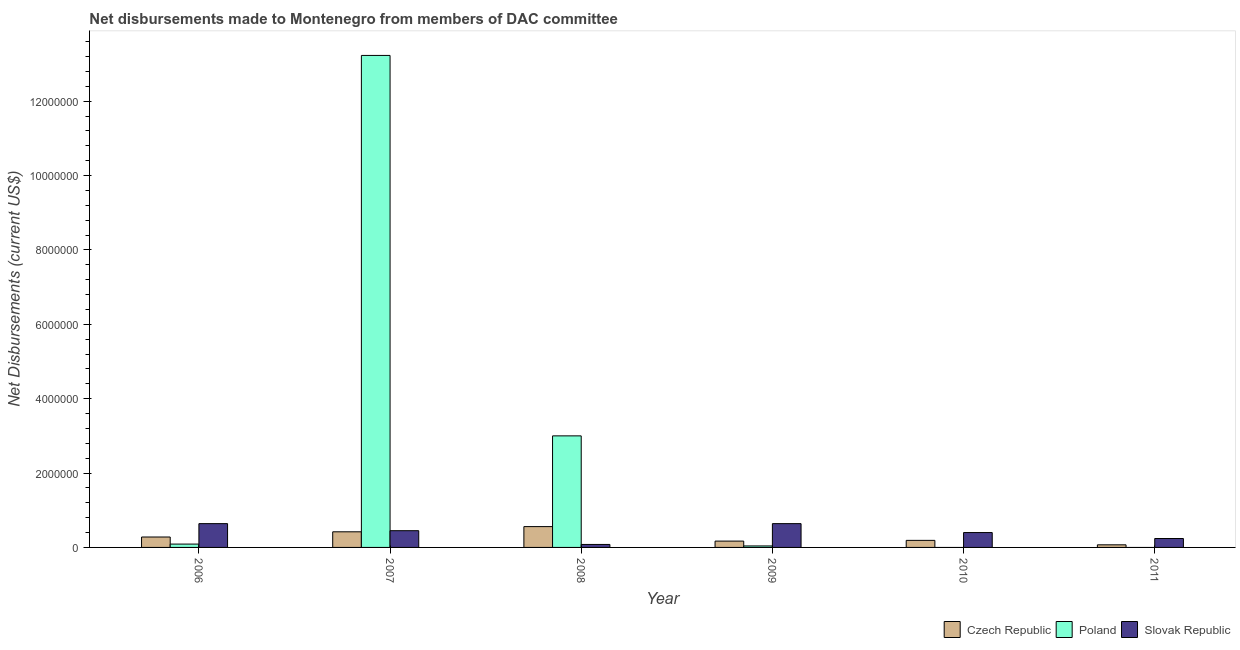How many different coloured bars are there?
Your answer should be compact. 3. How many bars are there on the 4th tick from the right?
Give a very brief answer. 3. In how many cases, is the number of bars for a given year not equal to the number of legend labels?
Ensure brevity in your answer.  2. What is the net disbursements made by czech republic in 2007?
Your answer should be very brief. 4.20e+05. Across all years, what is the maximum net disbursements made by slovak republic?
Provide a short and direct response. 6.40e+05. Across all years, what is the minimum net disbursements made by slovak republic?
Keep it short and to the point. 8.00e+04. In which year was the net disbursements made by slovak republic maximum?
Your answer should be compact. 2006. What is the total net disbursements made by czech republic in the graph?
Your response must be concise. 1.69e+06. What is the difference between the net disbursements made by czech republic in 2010 and that in 2011?
Your answer should be very brief. 1.20e+05. What is the difference between the net disbursements made by slovak republic in 2010 and the net disbursements made by poland in 2009?
Your answer should be very brief. -2.40e+05. What is the average net disbursements made by slovak republic per year?
Ensure brevity in your answer.  4.08e+05. In how many years, is the net disbursements made by slovak republic greater than 8800000 US$?
Give a very brief answer. 0. What is the ratio of the net disbursements made by czech republic in 2006 to that in 2008?
Give a very brief answer. 0.5. What is the difference between the highest and the second highest net disbursements made by poland?
Offer a very short reply. 1.02e+07. What is the difference between the highest and the lowest net disbursements made by poland?
Your answer should be very brief. 1.32e+07. In how many years, is the net disbursements made by slovak republic greater than the average net disbursements made by slovak republic taken over all years?
Provide a short and direct response. 3. Is the sum of the net disbursements made by slovak republic in 2007 and 2009 greater than the maximum net disbursements made by czech republic across all years?
Offer a terse response. Yes. Does the graph contain any zero values?
Provide a short and direct response. Yes. How are the legend labels stacked?
Provide a succinct answer. Horizontal. What is the title of the graph?
Keep it short and to the point. Net disbursements made to Montenegro from members of DAC committee. What is the label or title of the X-axis?
Provide a short and direct response. Year. What is the label or title of the Y-axis?
Give a very brief answer. Net Disbursements (current US$). What is the Net Disbursements (current US$) in Slovak Republic in 2006?
Keep it short and to the point. 6.40e+05. What is the Net Disbursements (current US$) of Poland in 2007?
Provide a succinct answer. 1.32e+07. What is the Net Disbursements (current US$) in Czech Republic in 2008?
Your answer should be very brief. 5.60e+05. What is the Net Disbursements (current US$) in Poland in 2008?
Keep it short and to the point. 3.00e+06. What is the Net Disbursements (current US$) of Czech Republic in 2009?
Give a very brief answer. 1.70e+05. What is the Net Disbursements (current US$) of Poland in 2009?
Offer a very short reply. 4.00e+04. What is the Net Disbursements (current US$) in Slovak Republic in 2009?
Your answer should be very brief. 6.40e+05. What is the Net Disbursements (current US$) in Poland in 2010?
Provide a short and direct response. 0. What is the Net Disbursements (current US$) in Slovak Republic in 2010?
Your answer should be compact. 4.00e+05. What is the Net Disbursements (current US$) of Czech Republic in 2011?
Offer a very short reply. 7.00e+04. Across all years, what is the maximum Net Disbursements (current US$) in Czech Republic?
Give a very brief answer. 5.60e+05. Across all years, what is the maximum Net Disbursements (current US$) in Poland?
Offer a very short reply. 1.32e+07. Across all years, what is the maximum Net Disbursements (current US$) in Slovak Republic?
Your answer should be very brief. 6.40e+05. Across all years, what is the minimum Net Disbursements (current US$) of Czech Republic?
Your response must be concise. 7.00e+04. Across all years, what is the minimum Net Disbursements (current US$) of Poland?
Your response must be concise. 0. What is the total Net Disbursements (current US$) in Czech Republic in the graph?
Give a very brief answer. 1.69e+06. What is the total Net Disbursements (current US$) of Poland in the graph?
Ensure brevity in your answer.  1.64e+07. What is the total Net Disbursements (current US$) of Slovak Republic in the graph?
Ensure brevity in your answer.  2.45e+06. What is the difference between the Net Disbursements (current US$) in Poland in 2006 and that in 2007?
Provide a short and direct response. -1.31e+07. What is the difference between the Net Disbursements (current US$) in Czech Republic in 2006 and that in 2008?
Offer a terse response. -2.80e+05. What is the difference between the Net Disbursements (current US$) of Poland in 2006 and that in 2008?
Your answer should be very brief. -2.91e+06. What is the difference between the Net Disbursements (current US$) in Slovak Republic in 2006 and that in 2008?
Keep it short and to the point. 5.60e+05. What is the difference between the Net Disbursements (current US$) of Poland in 2006 and that in 2009?
Offer a terse response. 5.00e+04. What is the difference between the Net Disbursements (current US$) in Slovak Republic in 2006 and that in 2009?
Make the answer very short. 0. What is the difference between the Net Disbursements (current US$) of Czech Republic in 2006 and that in 2011?
Offer a very short reply. 2.10e+05. What is the difference between the Net Disbursements (current US$) of Czech Republic in 2007 and that in 2008?
Provide a short and direct response. -1.40e+05. What is the difference between the Net Disbursements (current US$) of Poland in 2007 and that in 2008?
Offer a very short reply. 1.02e+07. What is the difference between the Net Disbursements (current US$) in Slovak Republic in 2007 and that in 2008?
Ensure brevity in your answer.  3.70e+05. What is the difference between the Net Disbursements (current US$) of Poland in 2007 and that in 2009?
Provide a succinct answer. 1.32e+07. What is the difference between the Net Disbursements (current US$) of Slovak Republic in 2007 and that in 2009?
Provide a short and direct response. -1.90e+05. What is the difference between the Net Disbursements (current US$) of Slovak Republic in 2007 and that in 2010?
Give a very brief answer. 5.00e+04. What is the difference between the Net Disbursements (current US$) in Czech Republic in 2007 and that in 2011?
Offer a terse response. 3.50e+05. What is the difference between the Net Disbursements (current US$) of Poland in 2008 and that in 2009?
Offer a very short reply. 2.96e+06. What is the difference between the Net Disbursements (current US$) of Slovak Republic in 2008 and that in 2009?
Your response must be concise. -5.60e+05. What is the difference between the Net Disbursements (current US$) in Czech Republic in 2008 and that in 2010?
Provide a short and direct response. 3.70e+05. What is the difference between the Net Disbursements (current US$) in Slovak Republic in 2008 and that in 2010?
Ensure brevity in your answer.  -3.20e+05. What is the difference between the Net Disbursements (current US$) in Czech Republic in 2008 and that in 2011?
Your answer should be very brief. 4.90e+05. What is the difference between the Net Disbursements (current US$) of Slovak Republic in 2008 and that in 2011?
Your answer should be very brief. -1.60e+05. What is the difference between the Net Disbursements (current US$) of Czech Republic in 2009 and that in 2010?
Provide a succinct answer. -2.00e+04. What is the difference between the Net Disbursements (current US$) of Czech Republic in 2009 and that in 2011?
Provide a short and direct response. 1.00e+05. What is the difference between the Net Disbursements (current US$) in Slovak Republic in 2009 and that in 2011?
Your answer should be very brief. 4.00e+05. What is the difference between the Net Disbursements (current US$) of Czech Republic in 2010 and that in 2011?
Offer a very short reply. 1.20e+05. What is the difference between the Net Disbursements (current US$) in Czech Republic in 2006 and the Net Disbursements (current US$) in Poland in 2007?
Offer a terse response. -1.30e+07. What is the difference between the Net Disbursements (current US$) in Czech Republic in 2006 and the Net Disbursements (current US$) in Slovak Republic in 2007?
Offer a very short reply. -1.70e+05. What is the difference between the Net Disbursements (current US$) of Poland in 2006 and the Net Disbursements (current US$) of Slovak Republic in 2007?
Make the answer very short. -3.60e+05. What is the difference between the Net Disbursements (current US$) of Czech Republic in 2006 and the Net Disbursements (current US$) of Poland in 2008?
Your response must be concise. -2.72e+06. What is the difference between the Net Disbursements (current US$) in Czech Republic in 2006 and the Net Disbursements (current US$) in Slovak Republic in 2008?
Keep it short and to the point. 2.00e+05. What is the difference between the Net Disbursements (current US$) of Poland in 2006 and the Net Disbursements (current US$) of Slovak Republic in 2008?
Your response must be concise. 10000. What is the difference between the Net Disbursements (current US$) of Czech Republic in 2006 and the Net Disbursements (current US$) of Slovak Republic in 2009?
Your response must be concise. -3.60e+05. What is the difference between the Net Disbursements (current US$) of Poland in 2006 and the Net Disbursements (current US$) of Slovak Republic in 2009?
Offer a very short reply. -5.50e+05. What is the difference between the Net Disbursements (current US$) of Poland in 2006 and the Net Disbursements (current US$) of Slovak Republic in 2010?
Keep it short and to the point. -3.10e+05. What is the difference between the Net Disbursements (current US$) of Czech Republic in 2007 and the Net Disbursements (current US$) of Poland in 2008?
Offer a terse response. -2.58e+06. What is the difference between the Net Disbursements (current US$) of Poland in 2007 and the Net Disbursements (current US$) of Slovak Republic in 2008?
Ensure brevity in your answer.  1.32e+07. What is the difference between the Net Disbursements (current US$) in Poland in 2007 and the Net Disbursements (current US$) in Slovak Republic in 2009?
Your response must be concise. 1.26e+07. What is the difference between the Net Disbursements (current US$) in Poland in 2007 and the Net Disbursements (current US$) in Slovak Republic in 2010?
Keep it short and to the point. 1.28e+07. What is the difference between the Net Disbursements (current US$) of Poland in 2007 and the Net Disbursements (current US$) of Slovak Republic in 2011?
Make the answer very short. 1.30e+07. What is the difference between the Net Disbursements (current US$) in Czech Republic in 2008 and the Net Disbursements (current US$) in Poland in 2009?
Offer a terse response. 5.20e+05. What is the difference between the Net Disbursements (current US$) in Poland in 2008 and the Net Disbursements (current US$) in Slovak Republic in 2009?
Keep it short and to the point. 2.36e+06. What is the difference between the Net Disbursements (current US$) in Czech Republic in 2008 and the Net Disbursements (current US$) in Slovak Republic in 2010?
Provide a succinct answer. 1.60e+05. What is the difference between the Net Disbursements (current US$) of Poland in 2008 and the Net Disbursements (current US$) of Slovak Republic in 2010?
Your response must be concise. 2.60e+06. What is the difference between the Net Disbursements (current US$) of Poland in 2008 and the Net Disbursements (current US$) of Slovak Republic in 2011?
Keep it short and to the point. 2.76e+06. What is the difference between the Net Disbursements (current US$) in Czech Republic in 2009 and the Net Disbursements (current US$) in Slovak Republic in 2010?
Provide a succinct answer. -2.30e+05. What is the difference between the Net Disbursements (current US$) in Poland in 2009 and the Net Disbursements (current US$) in Slovak Republic in 2010?
Offer a terse response. -3.60e+05. What is the difference between the Net Disbursements (current US$) of Czech Republic in 2010 and the Net Disbursements (current US$) of Slovak Republic in 2011?
Give a very brief answer. -5.00e+04. What is the average Net Disbursements (current US$) of Czech Republic per year?
Offer a very short reply. 2.82e+05. What is the average Net Disbursements (current US$) in Poland per year?
Provide a short and direct response. 2.73e+06. What is the average Net Disbursements (current US$) in Slovak Republic per year?
Offer a very short reply. 4.08e+05. In the year 2006, what is the difference between the Net Disbursements (current US$) of Czech Republic and Net Disbursements (current US$) of Poland?
Your answer should be very brief. 1.90e+05. In the year 2006, what is the difference between the Net Disbursements (current US$) of Czech Republic and Net Disbursements (current US$) of Slovak Republic?
Keep it short and to the point. -3.60e+05. In the year 2006, what is the difference between the Net Disbursements (current US$) of Poland and Net Disbursements (current US$) of Slovak Republic?
Your response must be concise. -5.50e+05. In the year 2007, what is the difference between the Net Disbursements (current US$) of Czech Republic and Net Disbursements (current US$) of Poland?
Your answer should be compact. -1.28e+07. In the year 2007, what is the difference between the Net Disbursements (current US$) in Poland and Net Disbursements (current US$) in Slovak Republic?
Your response must be concise. 1.28e+07. In the year 2008, what is the difference between the Net Disbursements (current US$) of Czech Republic and Net Disbursements (current US$) of Poland?
Your answer should be very brief. -2.44e+06. In the year 2008, what is the difference between the Net Disbursements (current US$) in Czech Republic and Net Disbursements (current US$) in Slovak Republic?
Offer a very short reply. 4.80e+05. In the year 2008, what is the difference between the Net Disbursements (current US$) in Poland and Net Disbursements (current US$) in Slovak Republic?
Provide a succinct answer. 2.92e+06. In the year 2009, what is the difference between the Net Disbursements (current US$) of Czech Republic and Net Disbursements (current US$) of Slovak Republic?
Your answer should be very brief. -4.70e+05. In the year 2009, what is the difference between the Net Disbursements (current US$) in Poland and Net Disbursements (current US$) in Slovak Republic?
Provide a succinct answer. -6.00e+05. In the year 2011, what is the difference between the Net Disbursements (current US$) in Czech Republic and Net Disbursements (current US$) in Slovak Republic?
Give a very brief answer. -1.70e+05. What is the ratio of the Net Disbursements (current US$) of Czech Republic in 2006 to that in 2007?
Make the answer very short. 0.67. What is the ratio of the Net Disbursements (current US$) in Poland in 2006 to that in 2007?
Offer a very short reply. 0.01. What is the ratio of the Net Disbursements (current US$) of Slovak Republic in 2006 to that in 2007?
Give a very brief answer. 1.42. What is the ratio of the Net Disbursements (current US$) in Czech Republic in 2006 to that in 2008?
Provide a succinct answer. 0.5. What is the ratio of the Net Disbursements (current US$) in Czech Republic in 2006 to that in 2009?
Provide a short and direct response. 1.65. What is the ratio of the Net Disbursements (current US$) of Poland in 2006 to that in 2009?
Make the answer very short. 2.25. What is the ratio of the Net Disbursements (current US$) in Czech Republic in 2006 to that in 2010?
Your answer should be compact. 1.47. What is the ratio of the Net Disbursements (current US$) of Slovak Republic in 2006 to that in 2010?
Ensure brevity in your answer.  1.6. What is the ratio of the Net Disbursements (current US$) in Slovak Republic in 2006 to that in 2011?
Keep it short and to the point. 2.67. What is the ratio of the Net Disbursements (current US$) in Poland in 2007 to that in 2008?
Make the answer very short. 4.41. What is the ratio of the Net Disbursements (current US$) in Slovak Republic in 2007 to that in 2008?
Your answer should be very brief. 5.62. What is the ratio of the Net Disbursements (current US$) in Czech Republic in 2007 to that in 2009?
Provide a short and direct response. 2.47. What is the ratio of the Net Disbursements (current US$) in Poland in 2007 to that in 2009?
Make the answer very short. 330.75. What is the ratio of the Net Disbursements (current US$) in Slovak Republic in 2007 to that in 2009?
Give a very brief answer. 0.7. What is the ratio of the Net Disbursements (current US$) in Czech Republic in 2007 to that in 2010?
Your response must be concise. 2.21. What is the ratio of the Net Disbursements (current US$) of Czech Republic in 2007 to that in 2011?
Your answer should be very brief. 6. What is the ratio of the Net Disbursements (current US$) in Slovak Republic in 2007 to that in 2011?
Provide a short and direct response. 1.88. What is the ratio of the Net Disbursements (current US$) of Czech Republic in 2008 to that in 2009?
Keep it short and to the point. 3.29. What is the ratio of the Net Disbursements (current US$) in Slovak Republic in 2008 to that in 2009?
Offer a terse response. 0.12. What is the ratio of the Net Disbursements (current US$) of Czech Republic in 2008 to that in 2010?
Provide a short and direct response. 2.95. What is the ratio of the Net Disbursements (current US$) of Czech Republic in 2008 to that in 2011?
Make the answer very short. 8. What is the ratio of the Net Disbursements (current US$) in Czech Republic in 2009 to that in 2010?
Your answer should be very brief. 0.89. What is the ratio of the Net Disbursements (current US$) of Slovak Republic in 2009 to that in 2010?
Your answer should be compact. 1.6. What is the ratio of the Net Disbursements (current US$) in Czech Republic in 2009 to that in 2011?
Offer a very short reply. 2.43. What is the ratio of the Net Disbursements (current US$) in Slovak Republic in 2009 to that in 2011?
Provide a short and direct response. 2.67. What is the ratio of the Net Disbursements (current US$) in Czech Republic in 2010 to that in 2011?
Your answer should be very brief. 2.71. What is the ratio of the Net Disbursements (current US$) in Slovak Republic in 2010 to that in 2011?
Ensure brevity in your answer.  1.67. What is the difference between the highest and the second highest Net Disbursements (current US$) in Czech Republic?
Ensure brevity in your answer.  1.40e+05. What is the difference between the highest and the second highest Net Disbursements (current US$) of Poland?
Provide a succinct answer. 1.02e+07. What is the difference between the highest and the lowest Net Disbursements (current US$) in Poland?
Your response must be concise. 1.32e+07. What is the difference between the highest and the lowest Net Disbursements (current US$) in Slovak Republic?
Provide a short and direct response. 5.60e+05. 